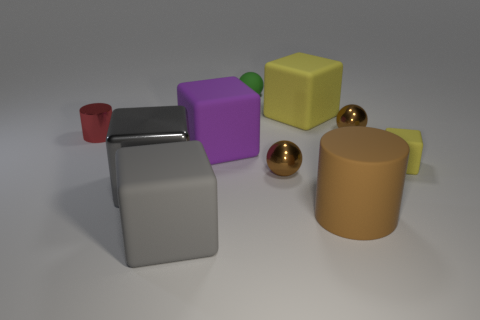What materials do the objects in the image appear to be made of? The objects in the image seem to be made of different materials. The shiny blocks look metallic due to their reflective properties, while the matte blocks resemble a more plastic or rubber-like material due to their diffuse surfaces. 